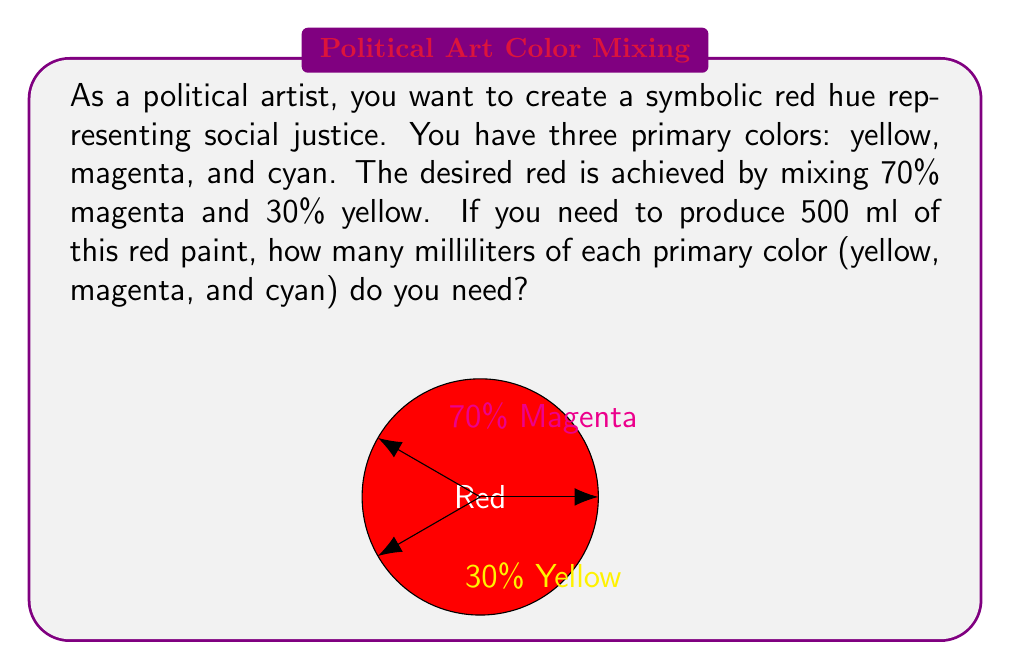Teach me how to tackle this problem. Let's approach this step-by-step:

1) First, we need to calculate the amount of each color in the mixture:

   Magenta: 70% of 500 ml
   $$ 500 \times 0.70 = 350 \text{ ml} $$

   Yellow: 30% of 500 ml
   $$ 500 \times 0.30 = 150 \text{ ml} $$

2) Cyan is not used in this mixture, so its amount is 0 ml.

3) To verify our calculations, let's check if the sum of all components equals the total volume:

   $$ 350 \text{ ml} + 150 \text{ ml} + 0 \text{ ml} = 500 \text{ ml} $$

   This confirms our calculations are correct.

4) Therefore, to create 500 ml of the symbolic red paint:
   - We need 350 ml of magenta
   - We need 150 ml of yellow
   - We need 0 ml of cyan
Answer: Magenta: 350 ml, Yellow: 150 ml, Cyan: 0 ml 